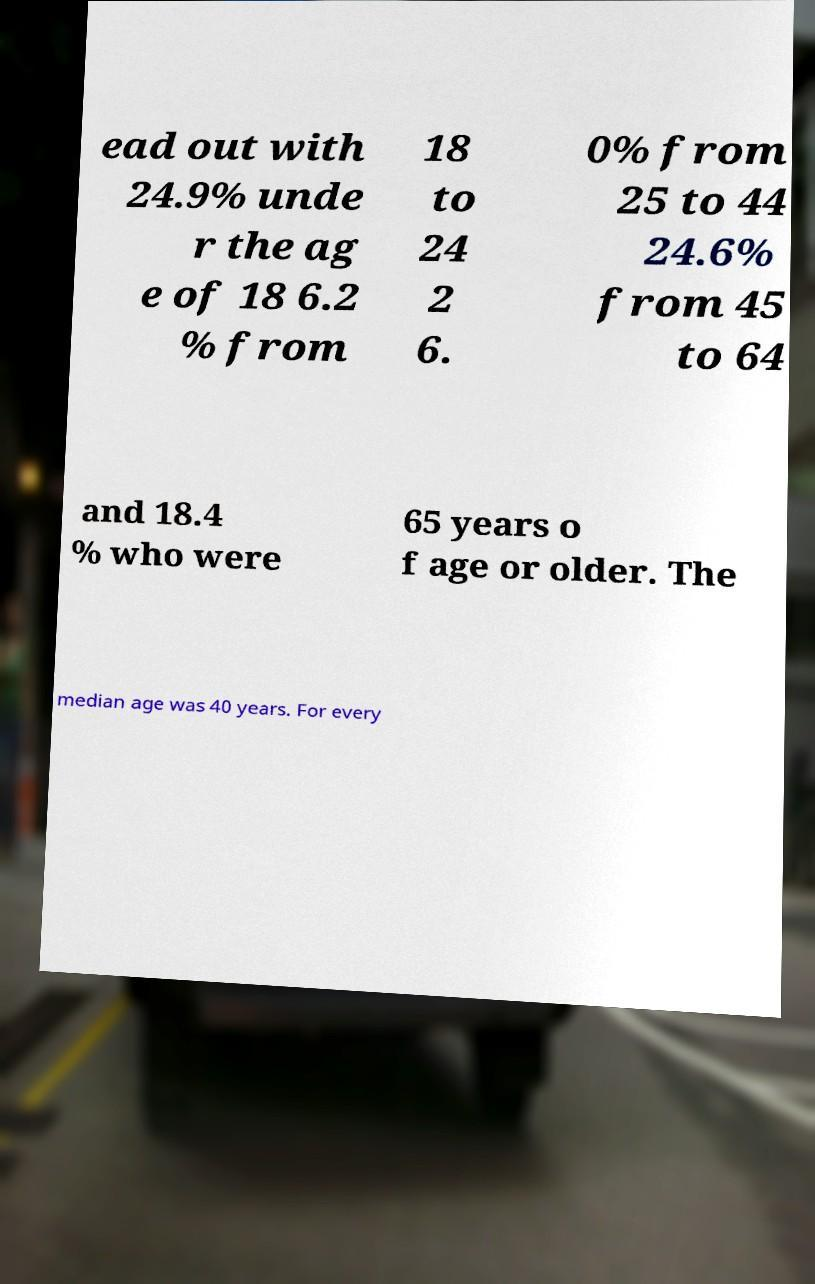Can you read and provide the text displayed in the image?This photo seems to have some interesting text. Can you extract and type it out for me? ead out with 24.9% unde r the ag e of 18 6.2 % from 18 to 24 2 6. 0% from 25 to 44 24.6% from 45 to 64 and 18.4 % who were 65 years o f age or older. The median age was 40 years. For every 